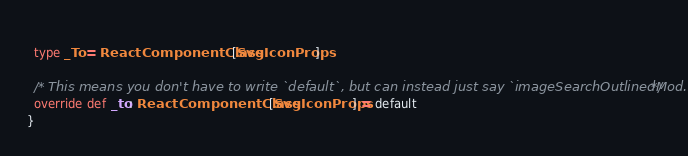Convert code to text. <code><loc_0><loc_0><loc_500><loc_500><_Scala_>  
  type _To = ReactComponentClass[SvgIconProps]
  
  /* This means you don't have to write `default`, but can instead just say `imageSearchOutlinedMod.foo` */
  override def _to: ReactComponentClass[SvgIconProps] = default
}
</code> 